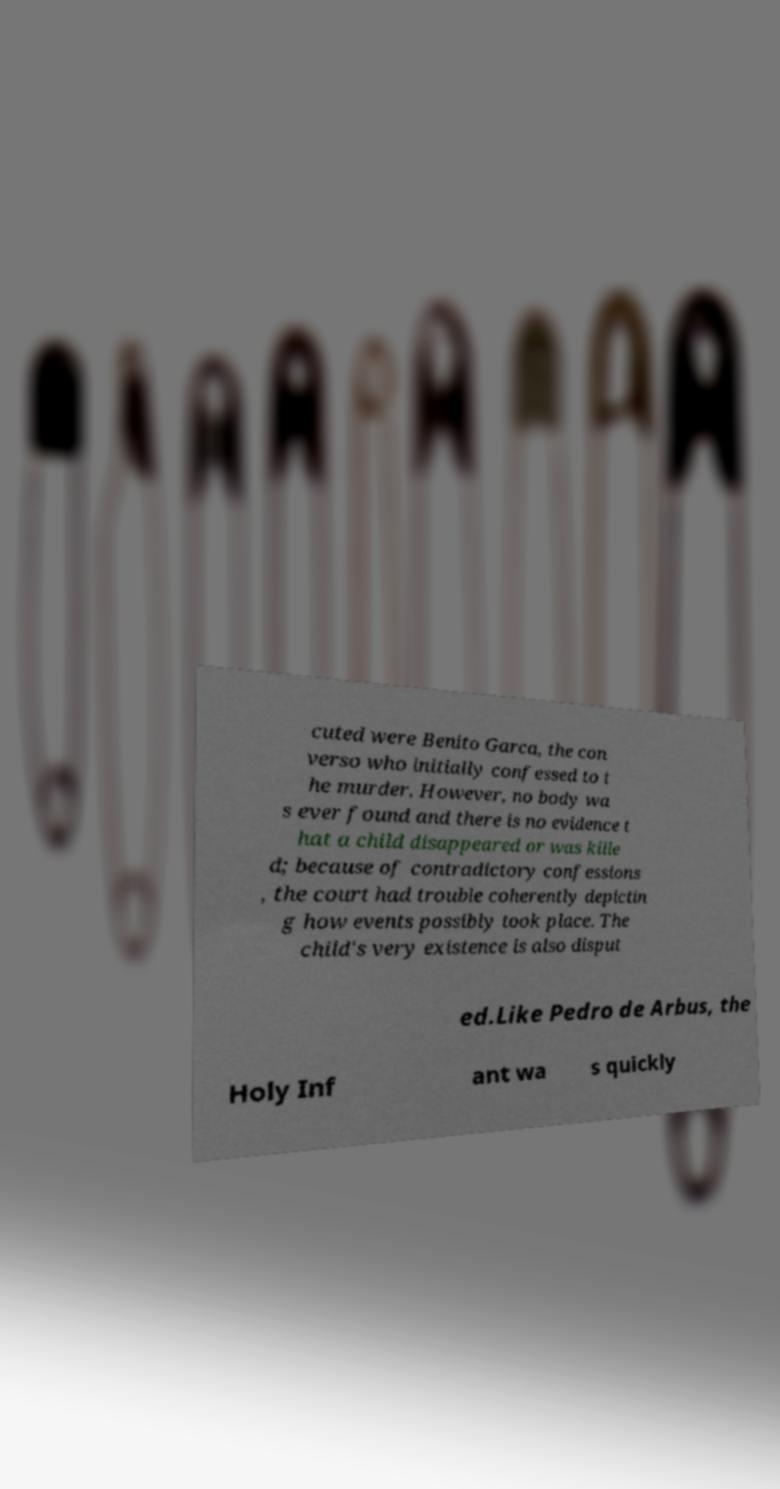Could you assist in decoding the text presented in this image and type it out clearly? cuted were Benito Garca, the con verso who initially confessed to t he murder. However, no body wa s ever found and there is no evidence t hat a child disappeared or was kille d; because of contradictory confessions , the court had trouble coherently depictin g how events possibly took place. The child's very existence is also disput ed.Like Pedro de Arbus, the Holy Inf ant wa s quickly 